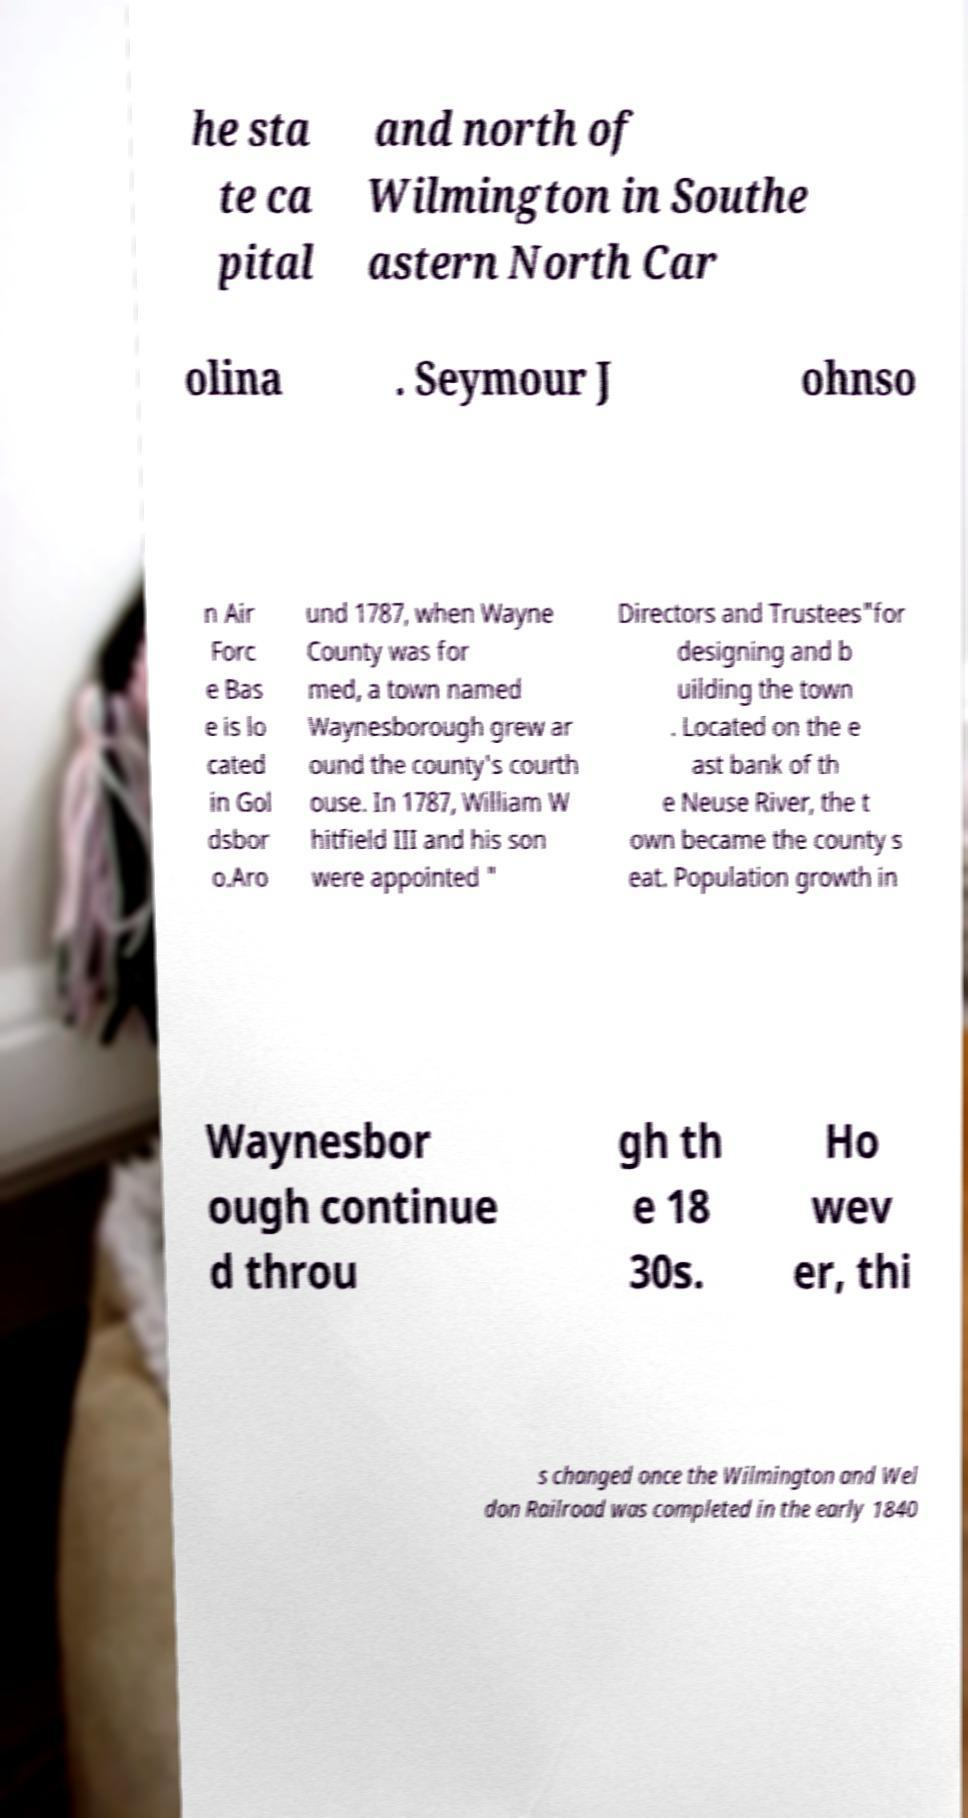For documentation purposes, I need the text within this image transcribed. Could you provide that? he sta te ca pital and north of Wilmington in Southe astern North Car olina . Seymour J ohnso n Air Forc e Bas e is lo cated in Gol dsbor o.Aro und 1787, when Wayne County was for med, a town named Waynesborough grew ar ound the county's courth ouse. In 1787, William W hitfield III and his son were appointed " Directors and Trustees"for designing and b uilding the town . Located on the e ast bank of th e Neuse River, the t own became the county s eat. Population growth in Waynesbor ough continue d throu gh th e 18 30s. Ho wev er, thi s changed once the Wilmington and Wel don Railroad was completed in the early 1840 